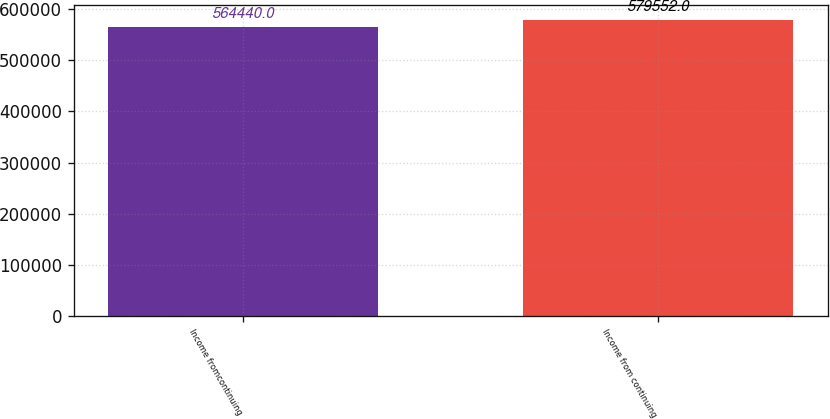Convert chart. <chart><loc_0><loc_0><loc_500><loc_500><bar_chart><fcel>Income fromcontinuing<fcel>Income from continuing<nl><fcel>564440<fcel>579552<nl></chart> 